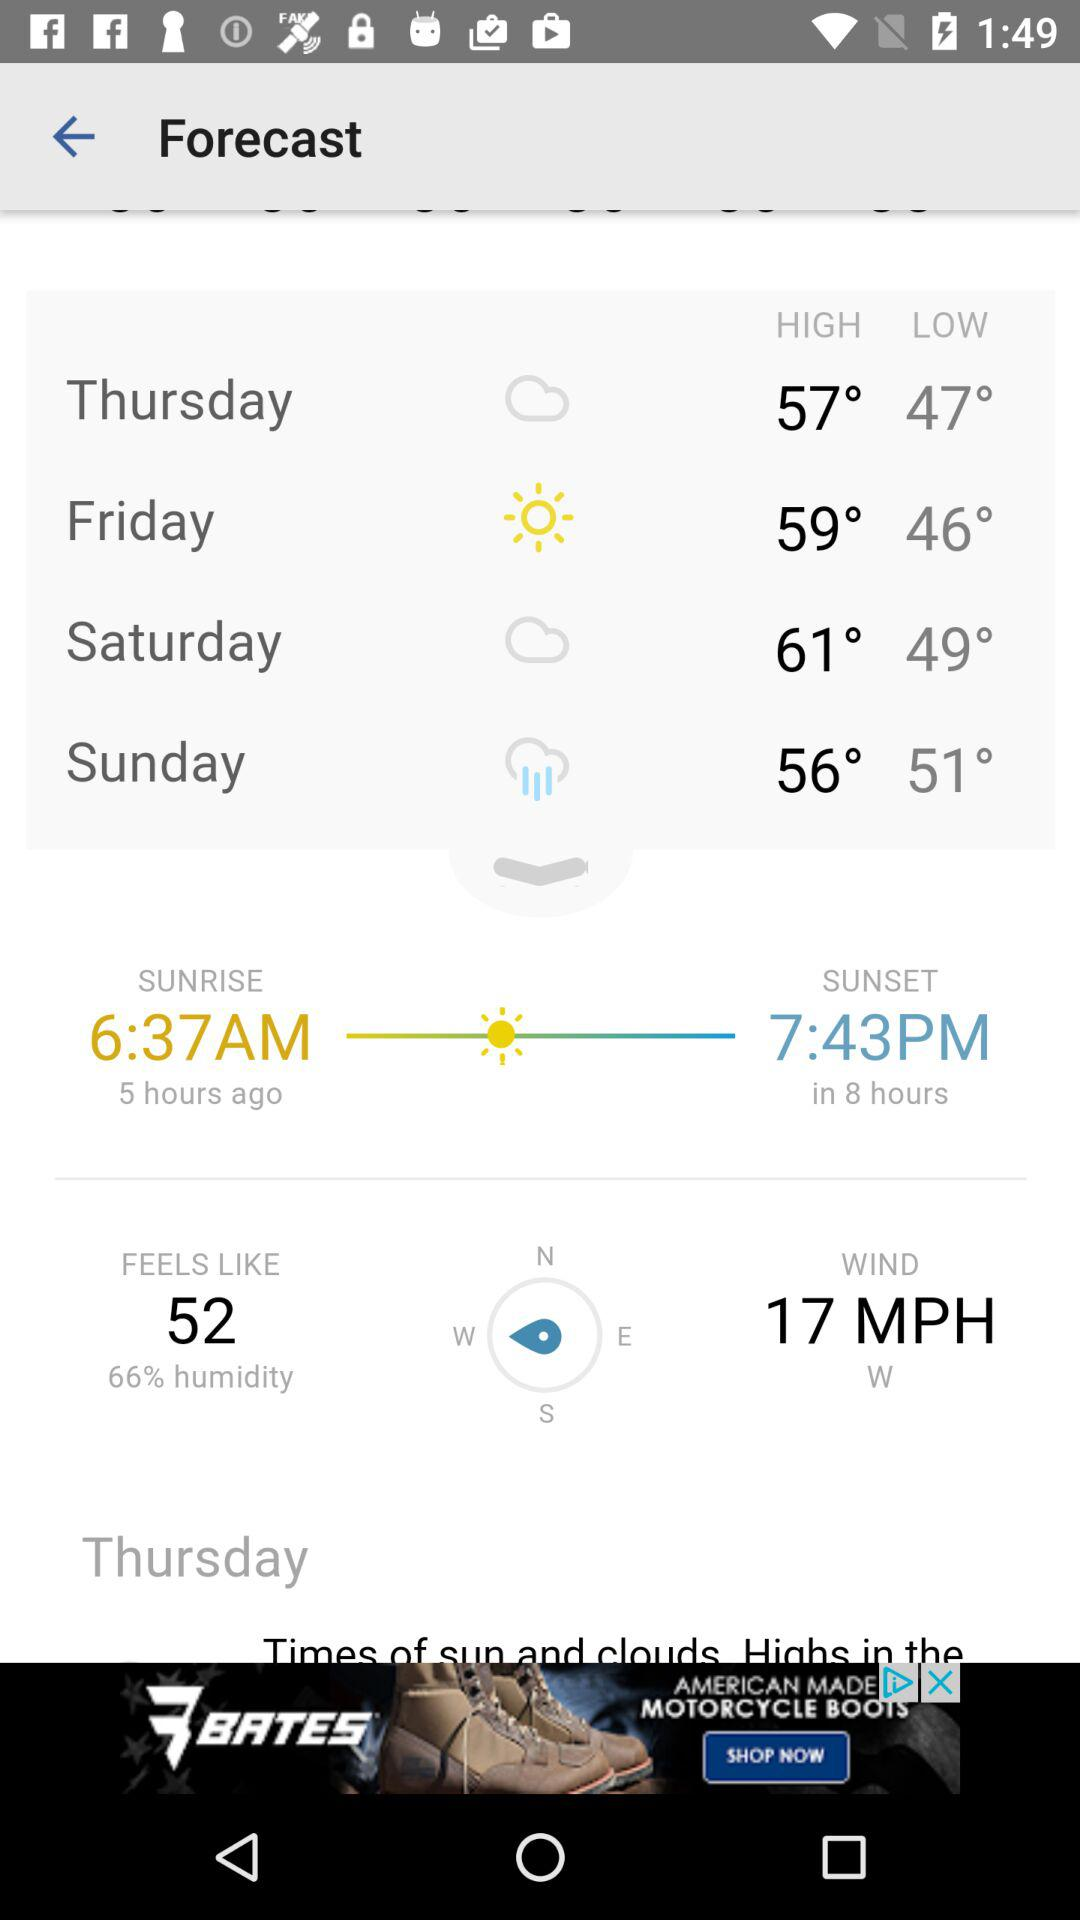What is the speed of the wind? The speed of the wind is 17 miles per hour. 